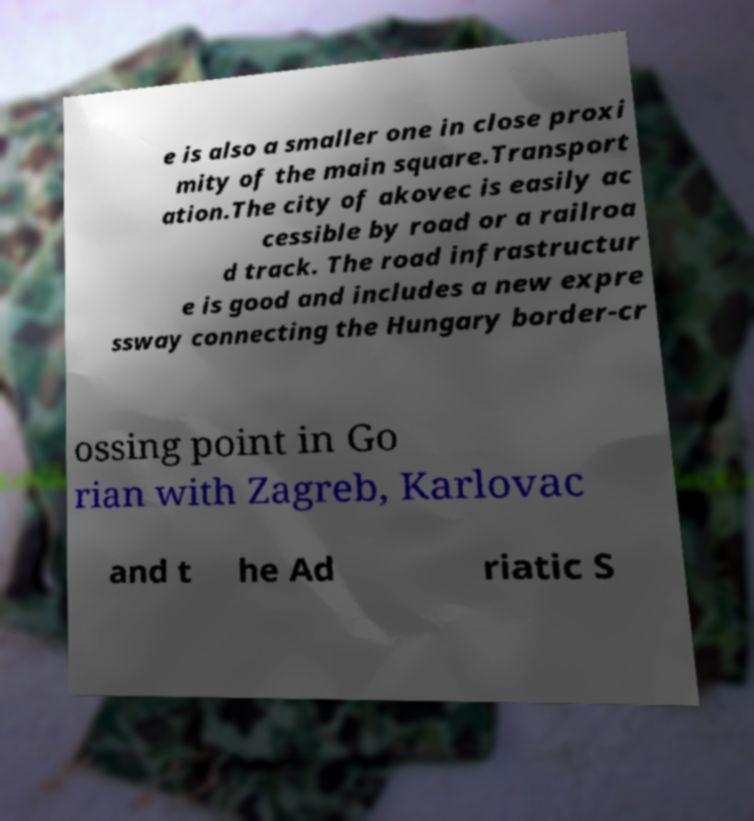Could you assist in decoding the text presented in this image and type it out clearly? e is also a smaller one in close proxi mity of the main square.Transport ation.The city of akovec is easily ac cessible by road or a railroa d track. The road infrastructur e is good and includes a new expre ssway connecting the Hungary border-cr ossing point in Go rian with Zagreb, Karlovac and t he Ad riatic S 